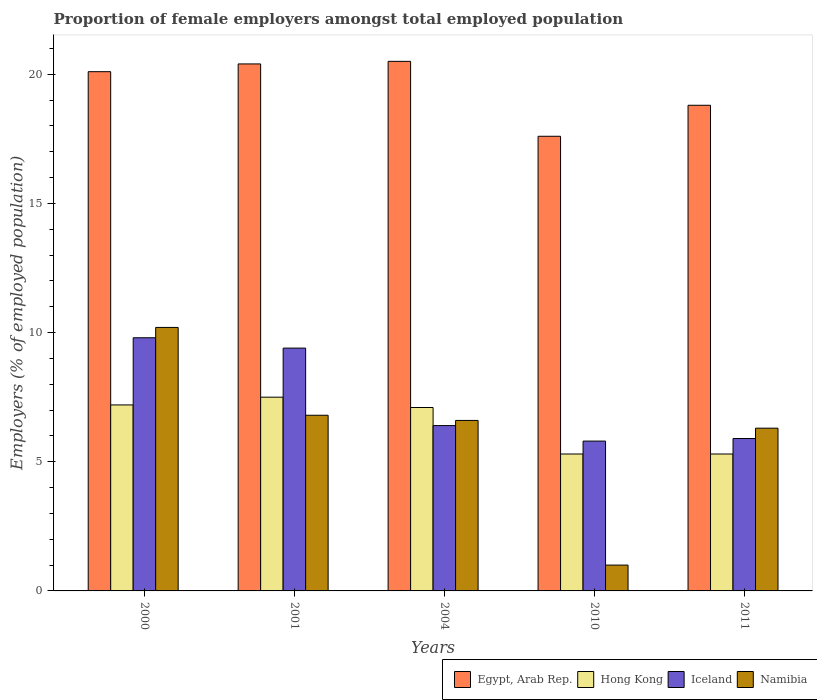How many different coloured bars are there?
Ensure brevity in your answer.  4. How many groups of bars are there?
Your response must be concise. 5. Are the number of bars per tick equal to the number of legend labels?
Your answer should be very brief. Yes. What is the proportion of female employers in Egypt, Arab Rep. in 2011?
Offer a terse response. 18.8. Across all years, what is the minimum proportion of female employers in Egypt, Arab Rep.?
Your answer should be very brief. 17.6. In which year was the proportion of female employers in Hong Kong maximum?
Your answer should be compact. 2001. In which year was the proportion of female employers in Egypt, Arab Rep. minimum?
Your answer should be compact. 2010. What is the total proportion of female employers in Hong Kong in the graph?
Ensure brevity in your answer.  32.4. What is the difference between the proportion of female employers in Iceland in 2001 and that in 2011?
Make the answer very short. 3.5. What is the difference between the proportion of female employers in Namibia in 2000 and the proportion of female employers in Iceland in 2004?
Keep it short and to the point. 3.8. What is the average proportion of female employers in Egypt, Arab Rep. per year?
Provide a short and direct response. 19.48. In the year 2010, what is the difference between the proportion of female employers in Iceland and proportion of female employers in Namibia?
Keep it short and to the point. 4.8. What is the ratio of the proportion of female employers in Iceland in 2010 to that in 2011?
Offer a terse response. 0.98. Is the proportion of female employers in Egypt, Arab Rep. in 2001 less than that in 2004?
Give a very brief answer. Yes. Is the difference between the proportion of female employers in Iceland in 2000 and 2011 greater than the difference between the proportion of female employers in Namibia in 2000 and 2011?
Your response must be concise. Yes. What is the difference between the highest and the second highest proportion of female employers in Namibia?
Offer a very short reply. 3.4. What is the difference between the highest and the lowest proportion of female employers in Hong Kong?
Ensure brevity in your answer.  2.2. What does the 4th bar from the left in 2010 represents?
Offer a terse response. Namibia. What does the 1st bar from the right in 2001 represents?
Your answer should be very brief. Namibia. Are all the bars in the graph horizontal?
Provide a short and direct response. No. Are the values on the major ticks of Y-axis written in scientific E-notation?
Provide a short and direct response. No. What is the title of the graph?
Provide a succinct answer. Proportion of female employers amongst total employed population. Does "Dominica" appear as one of the legend labels in the graph?
Make the answer very short. No. What is the label or title of the X-axis?
Your response must be concise. Years. What is the label or title of the Y-axis?
Give a very brief answer. Employers (% of employed population). What is the Employers (% of employed population) in Egypt, Arab Rep. in 2000?
Your response must be concise. 20.1. What is the Employers (% of employed population) of Hong Kong in 2000?
Your answer should be very brief. 7.2. What is the Employers (% of employed population) in Iceland in 2000?
Provide a succinct answer. 9.8. What is the Employers (% of employed population) of Namibia in 2000?
Offer a very short reply. 10.2. What is the Employers (% of employed population) of Egypt, Arab Rep. in 2001?
Your response must be concise. 20.4. What is the Employers (% of employed population) of Hong Kong in 2001?
Keep it short and to the point. 7.5. What is the Employers (% of employed population) in Iceland in 2001?
Offer a terse response. 9.4. What is the Employers (% of employed population) of Namibia in 2001?
Provide a succinct answer. 6.8. What is the Employers (% of employed population) in Egypt, Arab Rep. in 2004?
Give a very brief answer. 20.5. What is the Employers (% of employed population) of Hong Kong in 2004?
Ensure brevity in your answer.  7.1. What is the Employers (% of employed population) in Iceland in 2004?
Keep it short and to the point. 6.4. What is the Employers (% of employed population) of Namibia in 2004?
Provide a short and direct response. 6.6. What is the Employers (% of employed population) in Egypt, Arab Rep. in 2010?
Your response must be concise. 17.6. What is the Employers (% of employed population) in Hong Kong in 2010?
Your answer should be very brief. 5.3. What is the Employers (% of employed population) of Iceland in 2010?
Provide a succinct answer. 5.8. What is the Employers (% of employed population) of Egypt, Arab Rep. in 2011?
Provide a succinct answer. 18.8. What is the Employers (% of employed population) of Hong Kong in 2011?
Your answer should be very brief. 5.3. What is the Employers (% of employed population) in Iceland in 2011?
Give a very brief answer. 5.9. What is the Employers (% of employed population) of Namibia in 2011?
Give a very brief answer. 6.3. Across all years, what is the maximum Employers (% of employed population) of Egypt, Arab Rep.?
Your answer should be compact. 20.5. Across all years, what is the maximum Employers (% of employed population) of Iceland?
Give a very brief answer. 9.8. Across all years, what is the maximum Employers (% of employed population) of Namibia?
Offer a terse response. 10.2. Across all years, what is the minimum Employers (% of employed population) in Egypt, Arab Rep.?
Your answer should be compact. 17.6. Across all years, what is the minimum Employers (% of employed population) in Hong Kong?
Provide a short and direct response. 5.3. Across all years, what is the minimum Employers (% of employed population) in Iceland?
Give a very brief answer. 5.8. What is the total Employers (% of employed population) in Egypt, Arab Rep. in the graph?
Your answer should be very brief. 97.4. What is the total Employers (% of employed population) of Hong Kong in the graph?
Keep it short and to the point. 32.4. What is the total Employers (% of employed population) in Iceland in the graph?
Provide a short and direct response. 37.3. What is the total Employers (% of employed population) in Namibia in the graph?
Provide a succinct answer. 30.9. What is the difference between the Employers (% of employed population) of Egypt, Arab Rep. in 2000 and that in 2004?
Make the answer very short. -0.4. What is the difference between the Employers (% of employed population) in Hong Kong in 2000 and that in 2004?
Keep it short and to the point. 0.1. What is the difference between the Employers (% of employed population) in Iceland in 2000 and that in 2004?
Provide a short and direct response. 3.4. What is the difference between the Employers (% of employed population) of Namibia in 2000 and that in 2004?
Your answer should be compact. 3.6. What is the difference between the Employers (% of employed population) of Egypt, Arab Rep. in 2000 and that in 2010?
Your response must be concise. 2.5. What is the difference between the Employers (% of employed population) in Hong Kong in 2000 and that in 2010?
Keep it short and to the point. 1.9. What is the difference between the Employers (% of employed population) in Iceland in 2000 and that in 2011?
Give a very brief answer. 3.9. What is the difference between the Employers (% of employed population) of Hong Kong in 2001 and that in 2004?
Provide a short and direct response. 0.4. What is the difference between the Employers (% of employed population) in Iceland in 2001 and that in 2004?
Offer a very short reply. 3. What is the difference between the Employers (% of employed population) of Namibia in 2001 and that in 2004?
Provide a succinct answer. 0.2. What is the difference between the Employers (% of employed population) in Egypt, Arab Rep. in 2001 and that in 2010?
Offer a terse response. 2.8. What is the difference between the Employers (% of employed population) in Hong Kong in 2001 and that in 2010?
Your response must be concise. 2.2. What is the difference between the Employers (% of employed population) in Iceland in 2004 and that in 2010?
Give a very brief answer. 0.6. What is the difference between the Employers (% of employed population) of Egypt, Arab Rep. in 2010 and that in 2011?
Your response must be concise. -1.2. What is the difference between the Employers (% of employed population) in Hong Kong in 2010 and that in 2011?
Make the answer very short. 0. What is the difference between the Employers (% of employed population) of Iceland in 2010 and that in 2011?
Your answer should be compact. -0.1. What is the difference between the Employers (% of employed population) of Egypt, Arab Rep. in 2000 and the Employers (% of employed population) of Hong Kong in 2001?
Give a very brief answer. 12.6. What is the difference between the Employers (% of employed population) in Egypt, Arab Rep. in 2000 and the Employers (% of employed population) in Iceland in 2004?
Ensure brevity in your answer.  13.7. What is the difference between the Employers (% of employed population) in Egypt, Arab Rep. in 2000 and the Employers (% of employed population) in Namibia in 2004?
Ensure brevity in your answer.  13.5. What is the difference between the Employers (% of employed population) in Egypt, Arab Rep. in 2000 and the Employers (% of employed population) in Iceland in 2011?
Ensure brevity in your answer.  14.2. What is the difference between the Employers (% of employed population) of Egypt, Arab Rep. in 2000 and the Employers (% of employed population) of Namibia in 2011?
Offer a very short reply. 13.8. What is the difference between the Employers (% of employed population) of Hong Kong in 2000 and the Employers (% of employed population) of Iceland in 2011?
Offer a very short reply. 1.3. What is the difference between the Employers (% of employed population) of Iceland in 2000 and the Employers (% of employed population) of Namibia in 2011?
Provide a short and direct response. 3.5. What is the difference between the Employers (% of employed population) in Egypt, Arab Rep. in 2001 and the Employers (% of employed population) in Hong Kong in 2004?
Offer a very short reply. 13.3. What is the difference between the Employers (% of employed population) of Egypt, Arab Rep. in 2001 and the Employers (% of employed population) of Iceland in 2004?
Offer a very short reply. 14. What is the difference between the Employers (% of employed population) of Egypt, Arab Rep. in 2001 and the Employers (% of employed population) of Namibia in 2004?
Your answer should be very brief. 13.8. What is the difference between the Employers (% of employed population) of Hong Kong in 2001 and the Employers (% of employed population) of Iceland in 2004?
Your answer should be compact. 1.1. What is the difference between the Employers (% of employed population) in Hong Kong in 2001 and the Employers (% of employed population) in Namibia in 2004?
Ensure brevity in your answer.  0.9. What is the difference between the Employers (% of employed population) in Iceland in 2001 and the Employers (% of employed population) in Namibia in 2004?
Make the answer very short. 2.8. What is the difference between the Employers (% of employed population) of Egypt, Arab Rep. in 2001 and the Employers (% of employed population) of Hong Kong in 2010?
Ensure brevity in your answer.  15.1. What is the difference between the Employers (% of employed population) in Egypt, Arab Rep. in 2001 and the Employers (% of employed population) in Iceland in 2010?
Your answer should be very brief. 14.6. What is the difference between the Employers (% of employed population) of Egypt, Arab Rep. in 2001 and the Employers (% of employed population) of Namibia in 2010?
Offer a terse response. 19.4. What is the difference between the Employers (% of employed population) of Iceland in 2001 and the Employers (% of employed population) of Namibia in 2010?
Ensure brevity in your answer.  8.4. What is the difference between the Employers (% of employed population) in Egypt, Arab Rep. in 2001 and the Employers (% of employed population) in Namibia in 2011?
Give a very brief answer. 14.1. What is the difference between the Employers (% of employed population) in Hong Kong in 2001 and the Employers (% of employed population) in Iceland in 2011?
Offer a terse response. 1.6. What is the difference between the Employers (% of employed population) of Hong Kong in 2001 and the Employers (% of employed population) of Namibia in 2011?
Ensure brevity in your answer.  1.2. What is the difference between the Employers (% of employed population) in Egypt, Arab Rep. in 2004 and the Employers (% of employed population) in Iceland in 2010?
Ensure brevity in your answer.  14.7. What is the difference between the Employers (% of employed population) in Hong Kong in 2004 and the Employers (% of employed population) in Iceland in 2010?
Provide a succinct answer. 1.3. What is the difference between the Employers (% of employed population) of Iceland in 2004 and the Employers (% of employed population) of Namibia in 2010?
Keep it short and to the point. 5.4. What is the difference between the Employers (% of employed population) of Egypt, Arab Rep. in 2004 and the Employers (% of employed population) of Hong Kong in 2011?
Offer a terse response. 15.2. What is the difference between the Employers (% of employed population) of Egypt, Arab Rep. in 2004 and the Employers (% of employed population) of Iceland in 2011?
Your answer should be very brief. 14.6. What is the difference between the Employers (% of employed population) in Hong Kong in 2004 and the Employers (% of employed population) in Namibia in 2011?
Make the answer very short. 0.8. What is the difference between the Employers (% of employed population) of Iceland in 2004 and the Employers (% of employed population) of Namibia in 2011?
Make the answer very short. 0.1. What is the difference between the Employers (% of employed population) of Egypt, Arab Rep. in 2010 and the Employers (% of employed population) of Namibia in 2011?
Ensure brevity in your answer.  11.3. What is the difference between the Employers (% of employed population) in Iceland in 2010 and the Employers (% of employed population) in Namibia in 2011?
Your answer should be compact. -0.5. What is the average Employers (% of employed population) in Egypt, Arab Rep. per year?
Make the answer very short. 19.48. What is the average Employers (% of employed population) of Hong Kong per year?
Give a very brief answer. 6.48. What is the average Employers (% of employed population) of Iceland per year?
Offer a very short reply. 7.46. What is the average Employers (% of employed population) of Namibia per year?
Make the answer very short. 6.18. In the year 2000, what is the difference between the Employers (% of employed population) of Egypt, Arab Rep. and Employers (% of employed population) of Iceland?
Offer a very short reply. 10.3. In the year 2000, what is the difference between the Employers (% of employed population) of Hong Kong and Employers (% of employed population) of Namibia?
Keep it short and to the point. -3. In the year 2000, what is the difference between the Employers (% of employed population) in Iceland and Employers (% of employed population) in Namibia?
Ensure brevity in your answer.  -0.4. In the year 2001, what is the difference between the Employers (% of employed population) in Egypt, Arab Rep. and Employers (% of employed population) in Hong Kong?
Make the answer very short. 12.9. In the year 2001, what is the difference between the Employers (% of employed population) of Egypt, Arab Rep. and Employers (% of employed population) of Namibia?
Keep it short and to the point. 13.6. In the year 2001, what is the difference between the Employers (% of employed population) of Hong Kong and Employers (% of employed population) of Namibia?
Your answer should be very brief. 0.7. In the year 2004, what is the difference between the Employers (% of employed population) of Egypt, Arab Rep. and Employers (% of employed population) of Hong Kong?
Your answer should be very brief. 13.4. In the year 2004, what is the difference between the Employers (% of employed population) in Hong Kong and Employers (% of employed population) in Iceland?
Give a very brief answer. 0.7. In the year 2010, what is the difference between the Employers (% of employed population) in Egypt, Arab Rep. and Employers (% of employed population) in Namibia?
Provide a succinct answer. 16.6. In the year 2010, what is the difference between the Employers (% of employed population) of Hong Kong and Employers (% of employed population) of Iceland?
Make the answer very short. -0.5. In the year 2010, what is the difference between the Employers (% of employed population) in Iceland and Employers (% of employed population) in Namibia?
Your response must be concise. 4.8. In the year 2011, what is the difference between the Employers (% of employed population) in Egypt, Arab Rep. and Employers (% of employed population) in Iceland?
Your answer should be very brief. 12.9. In the year 2011, what is the difference between the Employers (% of employed population) of Egypt, Arab Rep. and Employers (% of employed population) of Namibia?
Provide a short and direct response. 12.5. In the year 2011, what is the difference between the Employers (% of employed population) of Hong Kong and Employers (% of employed population) of Namibia?
Your response must be concise. -1. In the year 2011, what is the difference between the Employers (% of employed population) in Iceland and Employers (% of employed population) in Namibia?
Ensure brevity in your answer.  -0.4. What is the ratio of the Employers (% of employed population) of Egypt, Arab Rep. in 2000 to that in 2001?
Ensure brevity in your answer.  0.99. What is the ratio of the Employers (% of employed population) in Iceland in 2000 to that in 2001?
Keep it short and to the point. 1.04. What is the ratio of the Employers (% of employed population) in Namibia in 2000 to that in 2001?
Provide a short and direct response. 1.5. What is the ratio of the Employers (% of employed population) of Egypt, Arab Rep. in 2000 to that in 2004?
Your answer should be very brief. 0.98. What is the ratio of the Employers (% of employed population) of Hong Kong in 2000 to that in 2004?
Ensure brevity in your answer.  1.01. What is the ratio of the Employers (% of employed population) of Iceland in 2000 to that in 2004?
Ensure brevity in your answer.  1.53. What is the ratio of the Employers (% of employed population) of Namibia in 2000 to that in 2004?
Provide a succinct answer. 1.55. What is the ratio of the Employers (% of employed population) in Egypt, Arab Rep. in 2000 to that in 2010?
Ensure brevity in your answer.  1.14. What is the ratio of the Employers (% of employed population) of Hong Kong in 2000 to that in 2010?
Your answer should be very brief. 1.36. What is the ratio of the Employers (% of employed population) in Iceland in 2000 to that in 2010?
Offer a terse response. 1.69. What is the ratio of the Employers (% of employed population) in Namibia in 2000 to that in 2010?
Your response must be concise. 10.2. What is the ratio of the Employers (% of employed population) of Egypt, Arab Rep. in 2000 to that in 2011?
Give a very brief answer. 1.07. What is the ratio of the Employers (% of employed population) in Hong Kong in 2000 to that in 2011?
Make the answer very short. 1.36. What is the ratio of the Employers (% of employed population) in Iceland in 2000 to that in 2011?
Your answer should be very brief. 1.66. What is the ratio of the Employers (% of employed population) of Namibia in 2000 to that in 2011?
Give a very brief answer. 1.62. What is the ratio of the Employers (% of employed population) in Egypt, Arab Rep. in 2001 to that in 2004?
Your answer should be compact. 1. What is the ratio of the Employers (% of employed population) of Hong Kong in 2001 to that in 2004?
Provide a short and direct response. 1.06. What is the ratio of the Employers (% of employed population) in Iceland in 2001 to that in 2004?
Make the answer very short. 1.47. What is the ratio of the Employers (% of employed population) of Namibia in 2001 to that in 2004?
Provide a succinct answer. 1.03. What is the ratio of the Employers (% of employed population) of Egypt, Arab Rep. in 2001 to that in 2010?
Provide a succinct answer. 1.16. What is the ratio of the Employers (% of employed population) in Hong Kong in 2001 to that in 2010?
Provide a short and direct response. 1.42. What is the ratio of the Employers (% of employed population) of Iceland in 2001 to that in 2010?
Your answer should be very brief. 1.62. What is the ratio of the Employers (% of employed population) in Namibia in 2001 to that in 2010?
Ensure brevity in your answer.  6.8. What is the ratio of the Employers (% of employed population) in Egypt, Arab Rep. in 2001 to that in 2011?
Your answer should be compact. 1.09. What is the ratio of the Employers (% of employed population) in Hong Kong in 2001 to that in 2011?
Make the answer very short. 1.42. What is the ratio of the Employers (% of employed population) of Iceland in 2001 to that in 2011?
Your answer should be very brief. 1.59. What is the ratio of the Employers (% of employed population) in Namibia in 2001 to that in 2011?
Offer a very short reply. 1.08. What is the ratio of the Employers (% of employed population) in Egypt, Arab Rep. in 2004 to that in 2010?
Provide a short and direct response. 1.16. What is the ratio of the Employers (% of employed population) in Hong Kong in 2004 to that in 2010?
Give a very brief answer. 1.34. What is the ratio of the Employers (% of employed population) of Iceland in 2004 to that in 2010?
Offer a very short reply. 1.1. What is the ratio of the Employers (% of employed population) of Namibia in 2004 to that in 2010?
Make the answer very short. 6.6. What is the ratio of the Employers (% of employed population) in Egypt, Arab Rep. in 2004 to that in 2011?
Your response must be concise. 1.09. What is the ratio of the Employers (% of employed population) in Hong Kong in 2004 to that in 2011?
Provide a short and direct response. 1.34. What is the ratio of the Employers (% of employed population) of Iceland in 2004 to that in 2011?
Offer a very short reply. 1.08. What is the ratio of the Employers (% of employed population) in Namibia in 2004 to that in 2011?
Provide a short and direct response. 1.05. What is the ratio of the Employers (% of employed population) in Egypt, Arab Rep. in 2010 to that in 2011?
Give a very brief answer. 0.94. What is the ratio of the Employers (% of employed population) in Hong Kong in 2010 to that in 2011?
Ensure brevity in your answer.  1. What is the ratio of the Employers (% of employed population) of Iceland in 2010 to that in 2011?
Keep it short and to the point. 0.98. What is the ratio of the Employers (% of employed population) of Namibia in 2010 to that in 2011?
Keep it short and to the point. 0.16. What is the difference between the highest and the second highest Employers (% of employed population) of Hong Kong?
Keep it short and to the point. 0.3. What is the difference between the highest and the second highest Employers (% of employed population) in Iceland?
Give a very brief answer. 0.4. What is the difference between the highest and the lowest Employers (% of employed population) in Hong Kong?
Keep it short and to the point. 2.2. What is the difference between the highest and the lowest Employers (% of employed population) in Namibia?
Provide a short and direct response. 9.2. 